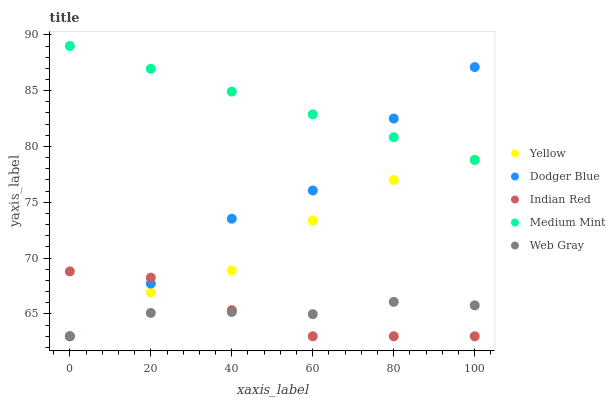Does Indian Red have the minimum area under the curve?
Answer yes or no. Yes. Does Medium Mint have the maximum area under the curve?
Answer yes or no. Yes. Does Web Gray have the minimum area under the curve?
Answer yes or no. No. Does Web Gray have the maximum area under the curve?
Answer yes or no. No. Is Medium Mint the smoothest?
Answer yes or no. Yes. Is Dodger Blue the roughest?
Answer yes or no. Yes. Is Web Gray the smoothest?
Answer yes or no. No. Is Web Gray the roughest?
Answer yes or no. No. Does Web Gray have the lowest value?
Answer yes or no. Yes. Does Medium Mint have the highest value?
Answer yes or no. Yes. Does Dodger Blue have the highest value?
Answer yes or no. No. Is Indian Red less than Medium Mint?
Answer yes or no. Yes. Is Medium Mint greater than Web Gray?
Answer yes or no. Yes. Does Dodger Blue intersect Indian Red?
Answer yes or no. Yes. Is Dodger Blue less than Indian Red?
Answer yes or no. No. Is Dodger Blue greater than Indian Red?
Answer yes or no. No. Does Indian Red intersect Medium Mint?
Answer yes or no. No. 